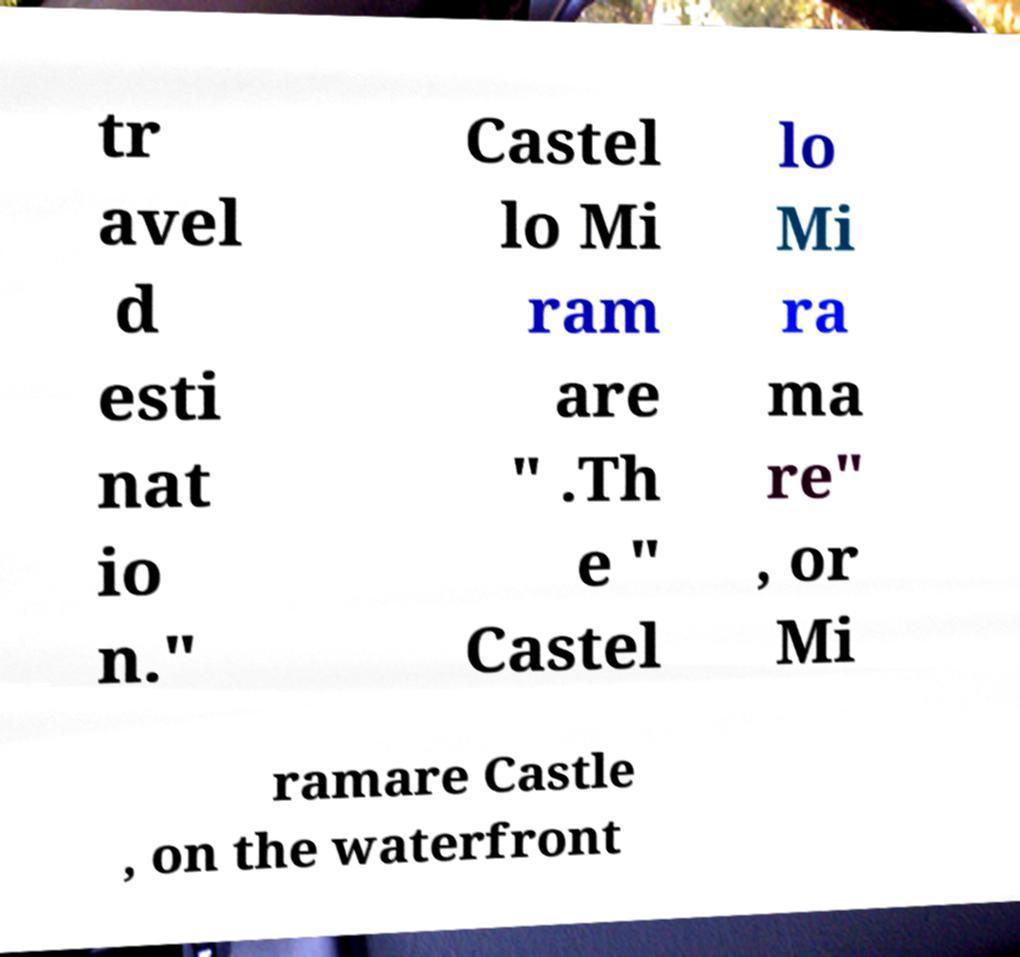For documentation purposes, I need the text within this image transcribed. Could you provide that? tr avel d esti nat io n." Castel lo Mi ram are " .Th e " Castel lo Mi ra ma re" , or Mi ramare Castle , on the waterfront 